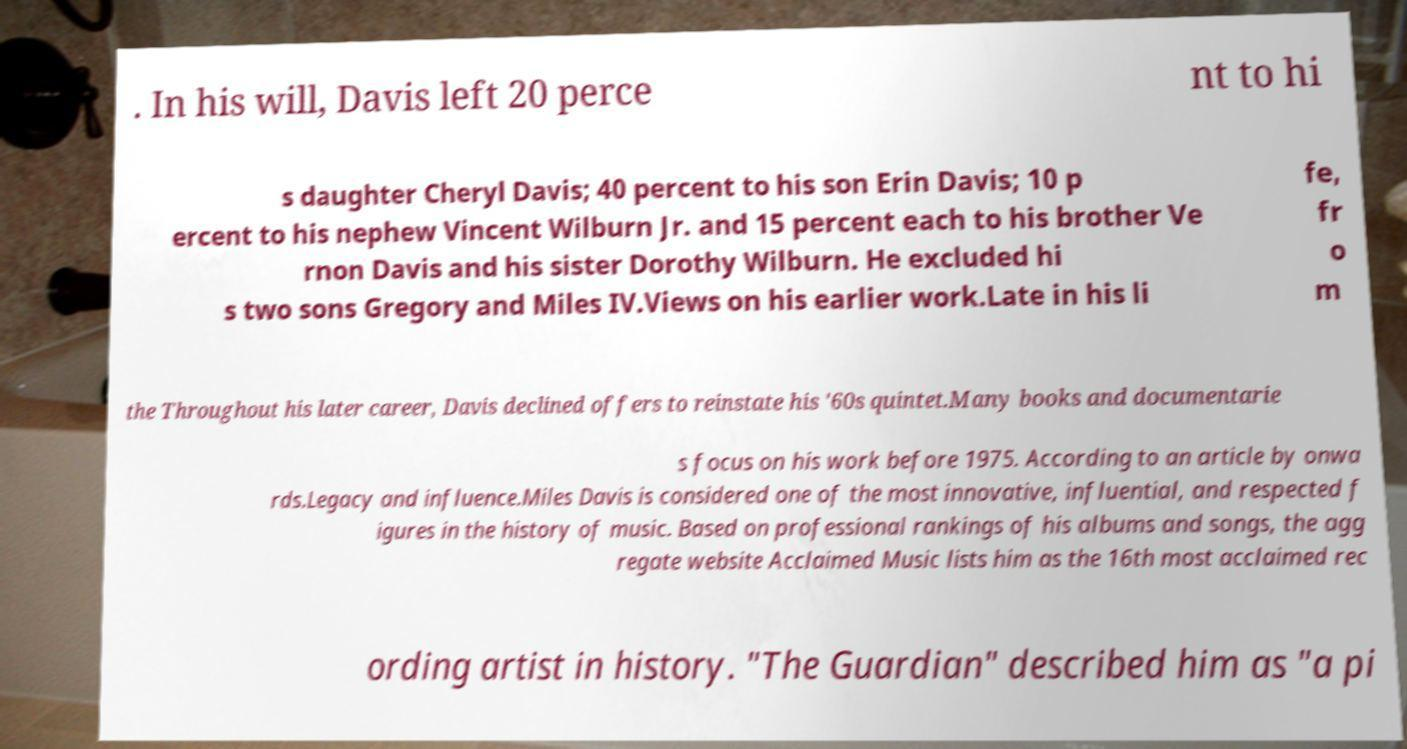Please identify and transcribe the text found in this image. . In his will, Davis left 20 perce nt to hi s daughter Cheryl Davis; 40 percent to his son Erin Davis; 10 p ercent to his nephew Vincent Wilburn Jr. and 15 percent each to his brother Ve rnon Davis and his sister Dorothy Wilburn. He excluded hi s two sons Gregory and Miles IV.Views on his earlier work.Late in his li fe, fr o m the Throughout his later career, Davis declined offers to reinstate his '60s quintet.Many books and documentarie s focus on his work before 1975. According to an article by onwa rds.Legacy and influence.Miles Davis is considered one of the most innovative, influential, and respected f igures in the history of music. Based on professional rankings of his albums and songs, the agg regate website Acclaimed Music lists him as the 16th most acclaimed rec ording artist in history. "The Guardian" described him as "a pi 